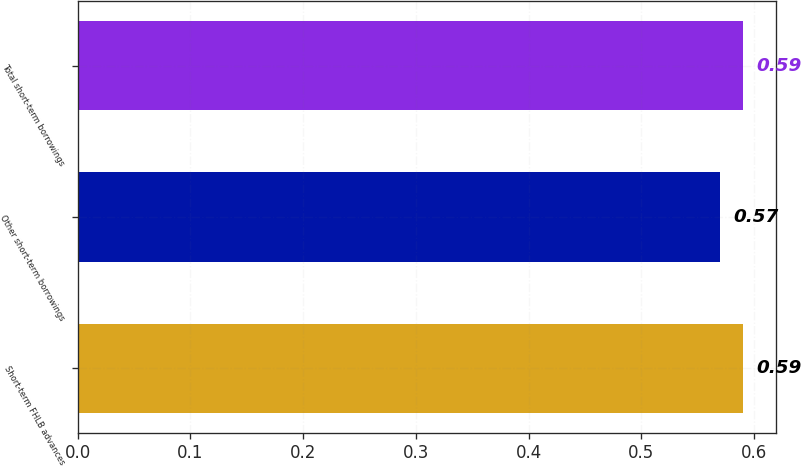<chart> <loc_0><loc_0><loc_500><loc_500><bar_chart><fcel>Short-term FHLB advances<fcel>Other short-term borrowings<fcel>Total short-term borrowings<nl><fcel>0.59<fcel>0.57<fcel>0.59<nl></chart> 